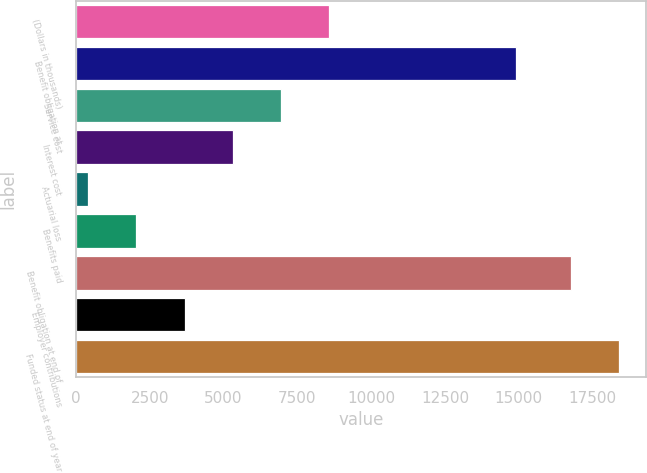Convert chart to OTSL. <chart><loc_0><loc_0><loc_500><loc_500><bar_chart><fcel>(Dollars in thousands)<fcel>Benefit obligation at<fcel>Service cost<fcel>Interest cost<fcel>Actuarial loss<fcel>Benefits paid<fcel>Benefit obligation at end of<fcel>Employer contributions<fcel>Funded status at end of year<nl><fcel>8583<fcel>14919<fcel>6948.8<fcel>5314.6<fcel>412<fcel>2046.2<fcel>16754<fcel>3680.4<fcel>18388.2<nl></chart> 